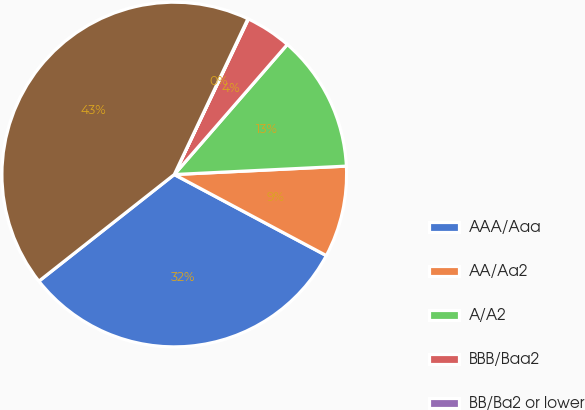<chart> <loc_0><loc_0><loc_500><loc_500><pie_chart><fcel>AAA/Aaa<fcel>AA/Aa2<fcel>A/A2<fcel>BBB/Baa2<fcel>BB/Ba2 or lower<fcel>Total<nl><fcel>31.58%<fcel>8.57%<fcel>12.83%<fcel>4.31%<fcel>0.05%<fcel>42.64%<nl></chart> 